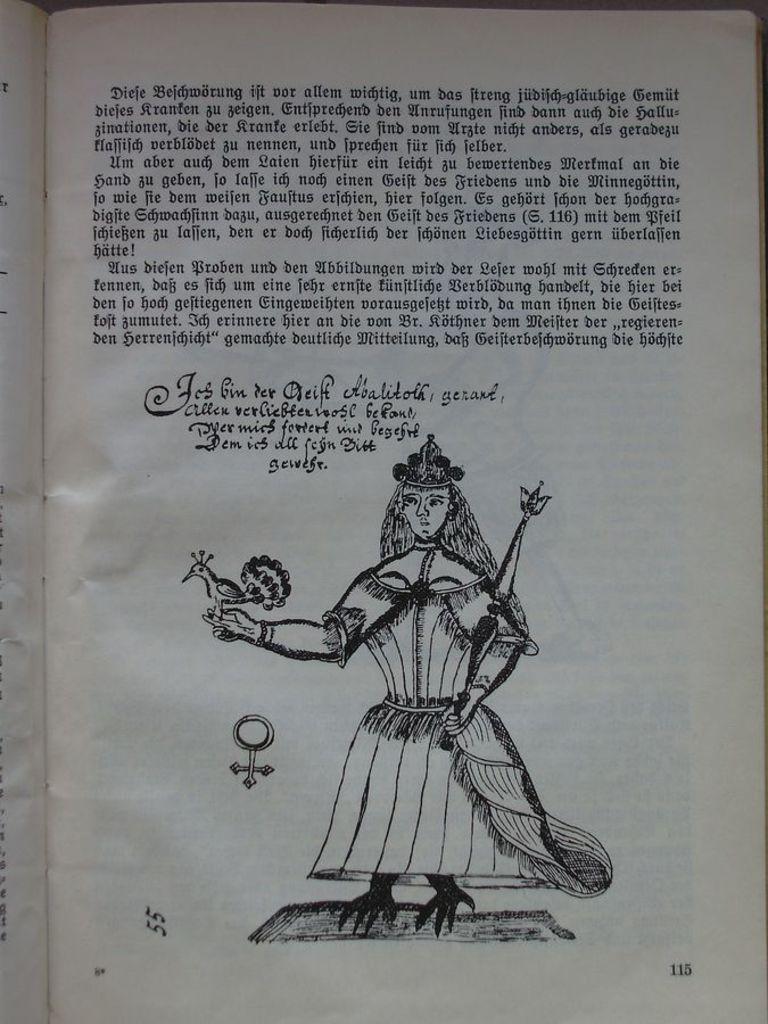How would you summarize this image in a sentence or two? In the image there is a print of a man holding a bird with text above it on a paper. 